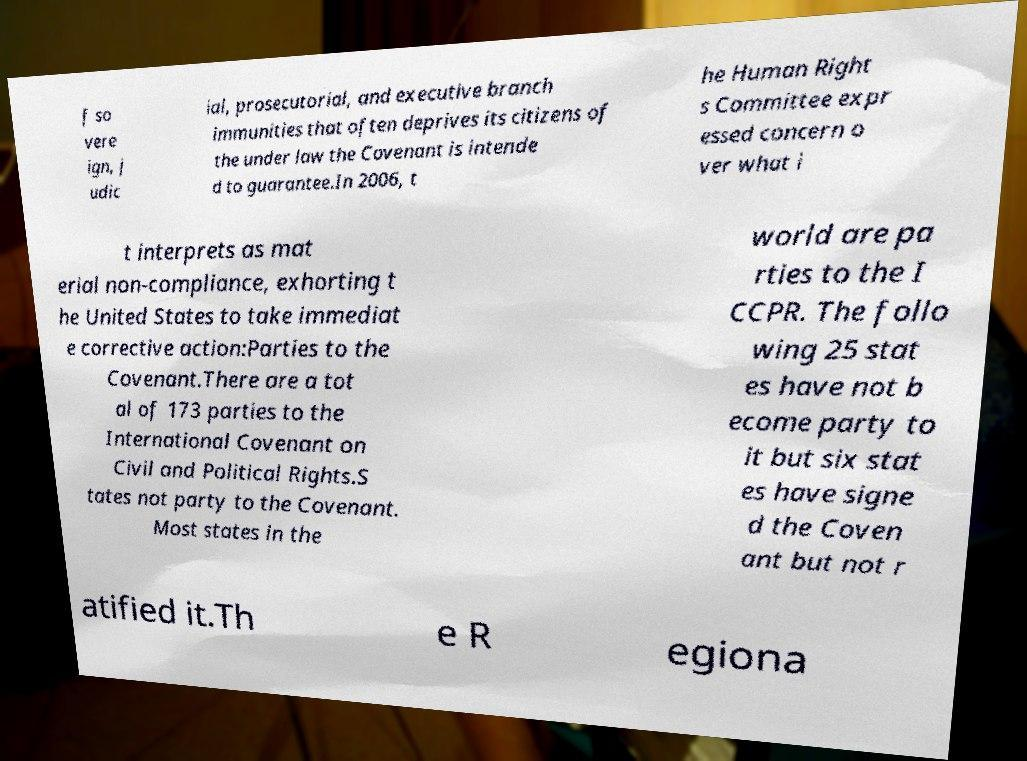I need the written content from this picture converted into text. Can you do that? f so vere ign, j udic ial, prosecutorial, and executive branch immunities that often deprives its citizens of the under law the Covenant is intende d to guarantee.In 2006, t he Human Right s Committee expr essed concern o ver what i t interprets as mat erial non-compliance, exhorting t he United States to take immediat e corrective action:Parties to the Covenant.There are a tot al of 173 parties to the International Covenant on Civil and Political Rights.S tates not party to the Covenant. Most states in the world are pa rties to the I CCPR. The follo wing 25 stat es have not b ecome party to it but six stat es have signe d the Coven ant but not r atified it.Th e R egiona 